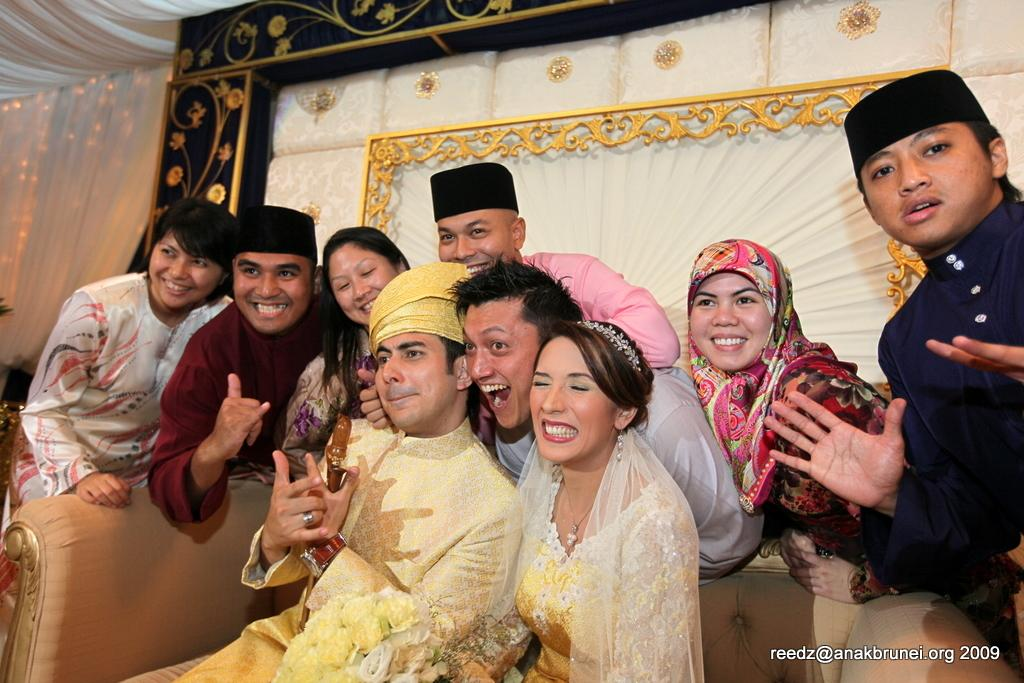How many people are in the image? There is a group of people in the image. What is the facial expression of the people in the image? The people are smiling. What can be seen in the background of the image? There are colorful designs in the background of the image. What type of blade is being used by the giants in the image? There are no giants or blades present in the image. 